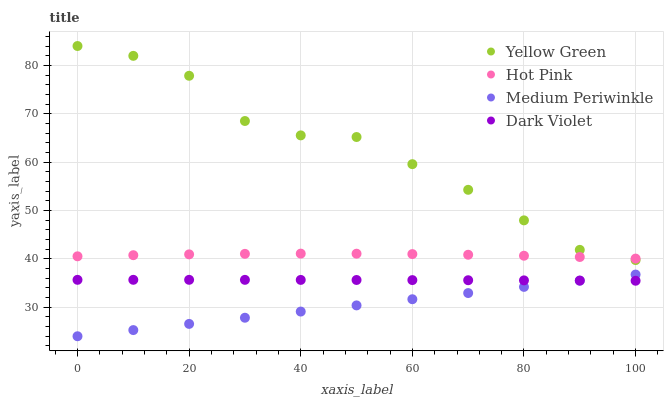Does Medium Periwinkle have the minimum area under the curve?
Answer yes or no. Yes. Does Yellow Green have the maximum area under the curve?
Answer yes or no. Yes. Does Yellow Green have the minimum area under the curve?
Answer yes or no. No. Does Medium Periwinkle have the maximum area under the curve?
Answer yes or no. No. Is Medium Periwinkle the smoothest?
Answer yes or no. Yes. Is Yellow Green the roughest?
Answer yes or no. Yes. Is Yellow Green the smoothest?
Answer yes or no. No. Is Medium Periwinkle the roughest?
Answer yes or no. No. Does Medium Periwinkle have the lowest value?
Answer yes or no. Yes. Does Yellow Green have the lowest value?
Answer yes or no. No. Does Yellow Green have the highest value?
Answer yes or no. Yes. Does Medium Periwinkle have the highest value?
Answer yes or no. No. Is Medium Periwinkle less than Yellow Green?
Answer yes or no. Yes. Is Hot Pink greater than Medium Periwinkle?
Answer yes or no. Yes. Does Yellow Green intersect Hot Pink?
Answer yes or no. Yes. Is Yellow Green less than Hot Pink?
Answer yes or no. No. Is Yellow Green greater than Hot Pink?
Answer yes or no. No. Does Medium Periwinkle intersect Yellow Green?
Answer yes or no. No. 